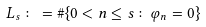Convert formula to latex. <formula><loc_0><loc_0><loc_500><loc_500>L _ { s } \colon = \# \{ 0 < n \leq s \colon \varphi _ { n } = 0 \}</formula> 